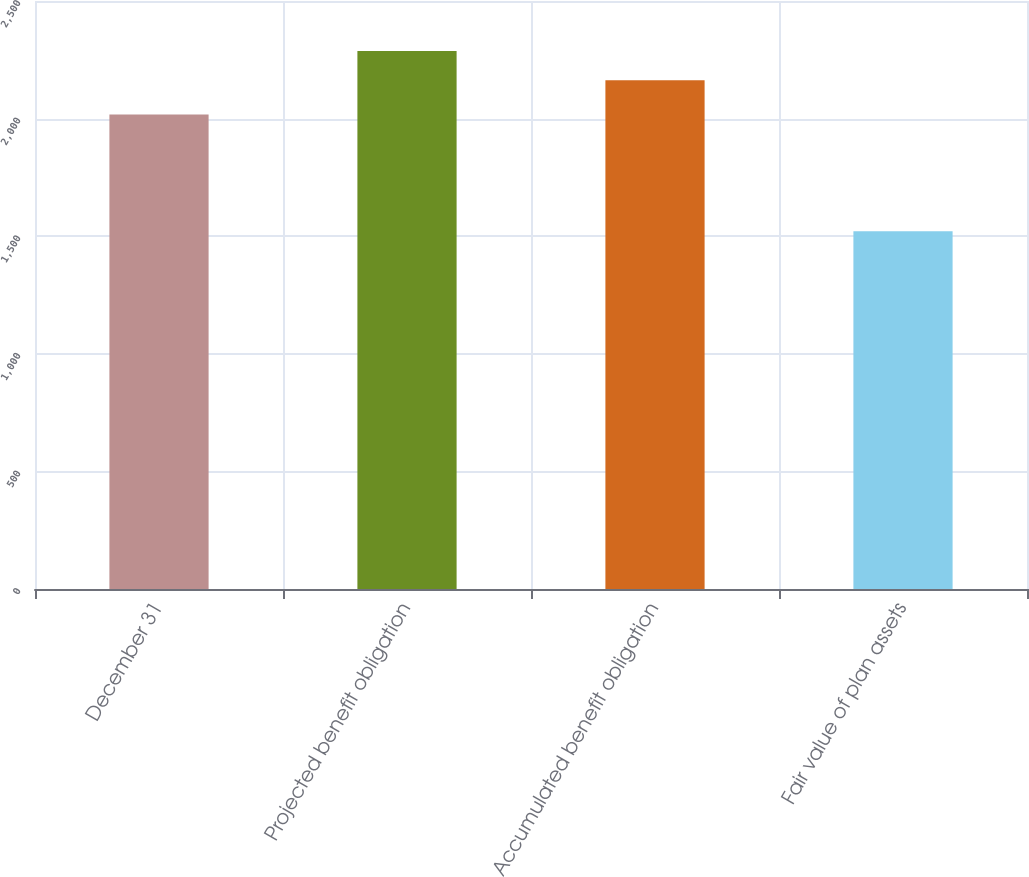<chart> <loc_0><loc_0><loc_500><loc_500><bar_chart><fcel>December 31<fcel>Projected benefit obligation<fcel>Accumulated benefit obligation<fcel>Fair value of plan assets<nl><fcel>2017<fcel>2287<fcel>2163<fcel>1521<nl></chart> 